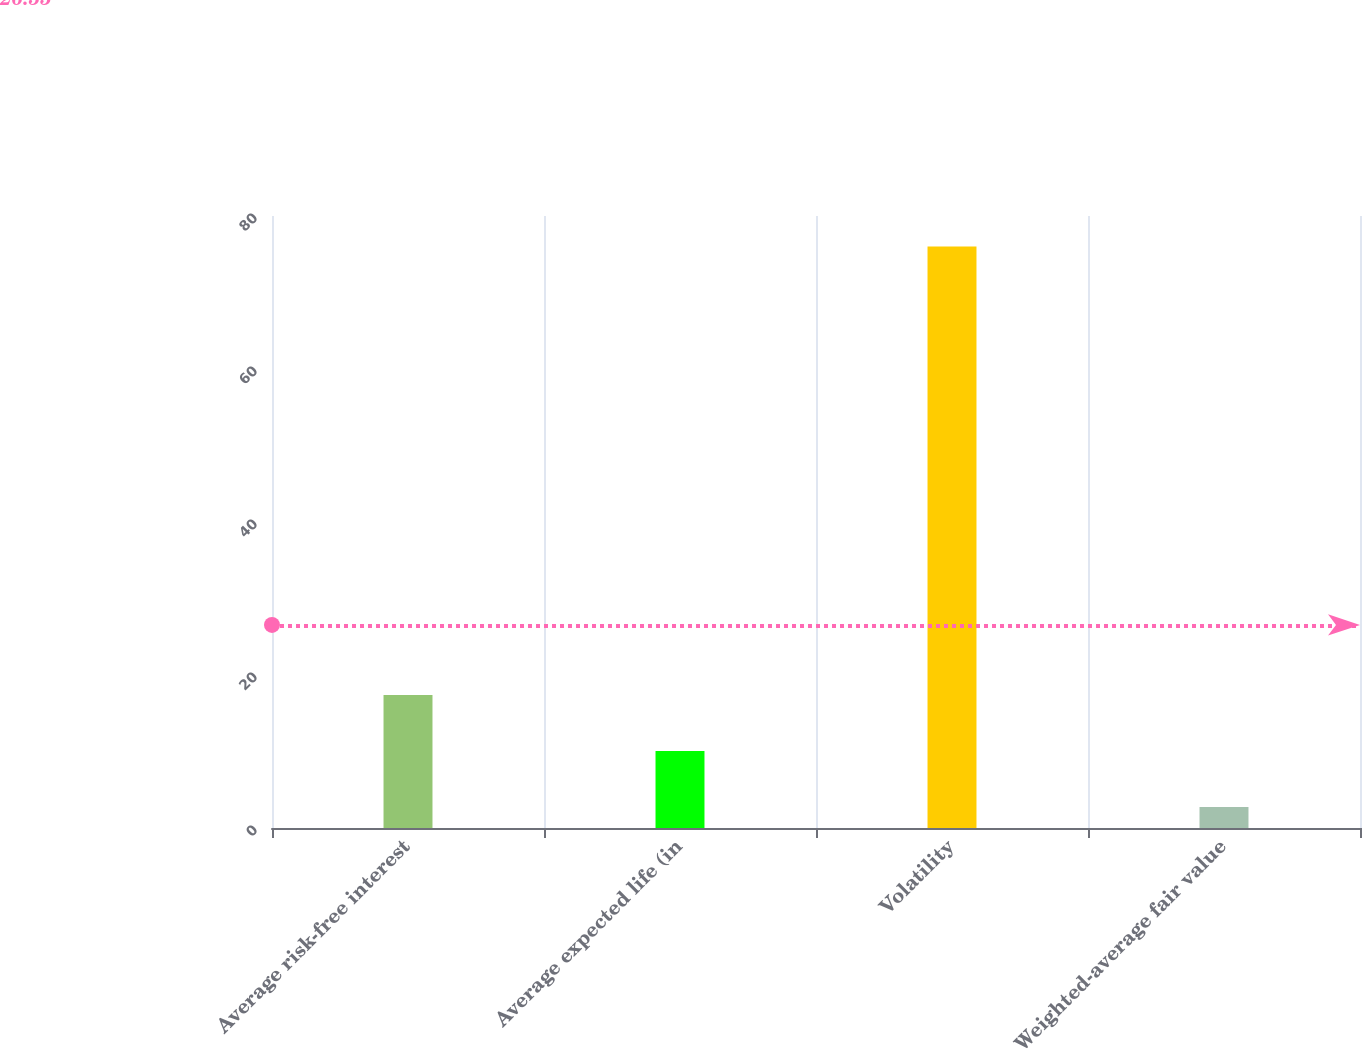Convert chart. <chart><loc_0><loc_0><loc_500><loc_500><bar_chart><fcel>Average risk-free interest<fcel>Average expected life (in<fcel>Volatility<fcel>Weighted-average fair value<nl><fcel>17.39<fcel>10.07<fcel>76<fcel>2.75<nl></chart> 